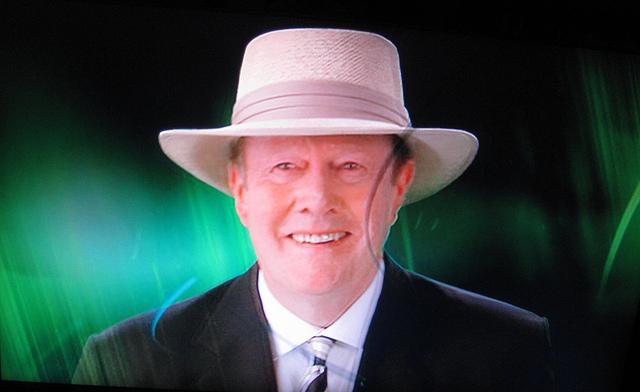Is the man wearing a tie?
Keep it brief. Yes. What color is the man's suit?
Answer briefly. Black. What is the name of the hat the man is wearing?
Short answer required. Fedora. Who wears a hat?
Short answer required. Man. 